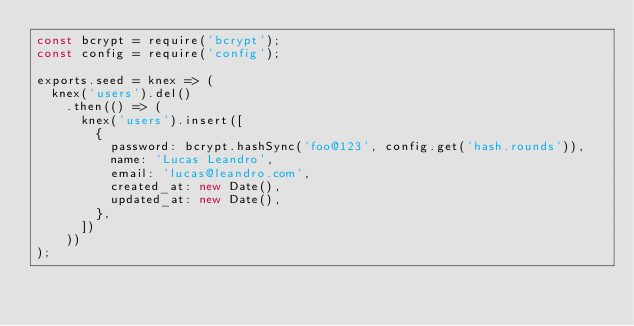<code> <loc_0><loc_0><loc_500><loc_500><_JavaScript_>const bcrypt = require('bcrypt');
const config = require('config');

exports.seed = knex => (
  knex('users').del()
    .then(() => (
      knex('users').insert([
        {
          password: bcrypt.hashSync('foo@123', config.get('hash.rounds')),
          name: 'Lucas Leandro',
          email: 'lucas@leandro.com',
          created_at: new Date(),
          updated_at: new Date(),
        },
      ])
    ))
);
</code> 